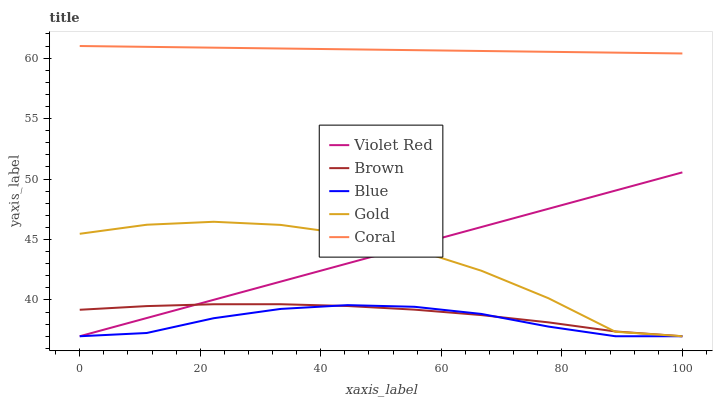Does Brown have the minimum area under the curve?
Answer yes or no. No. Does Brown have the maximum area under the curve?
Answer yes or no. No. Is Brown the smoothest?
Answer yes or no. No. Is Brown the roughest?
Answer yes or no. No. Does Coral have the lowest value?
Answer yes or no. No. Does Brown have the highest value?
Answer yes or no. No. Is Brown less than Coral?
Answer yes or no. Yes. Is Coral greater than Brown?
Answer yes or no. Yes. Does Brown intersect Coral?
Answer yes or no. No. 